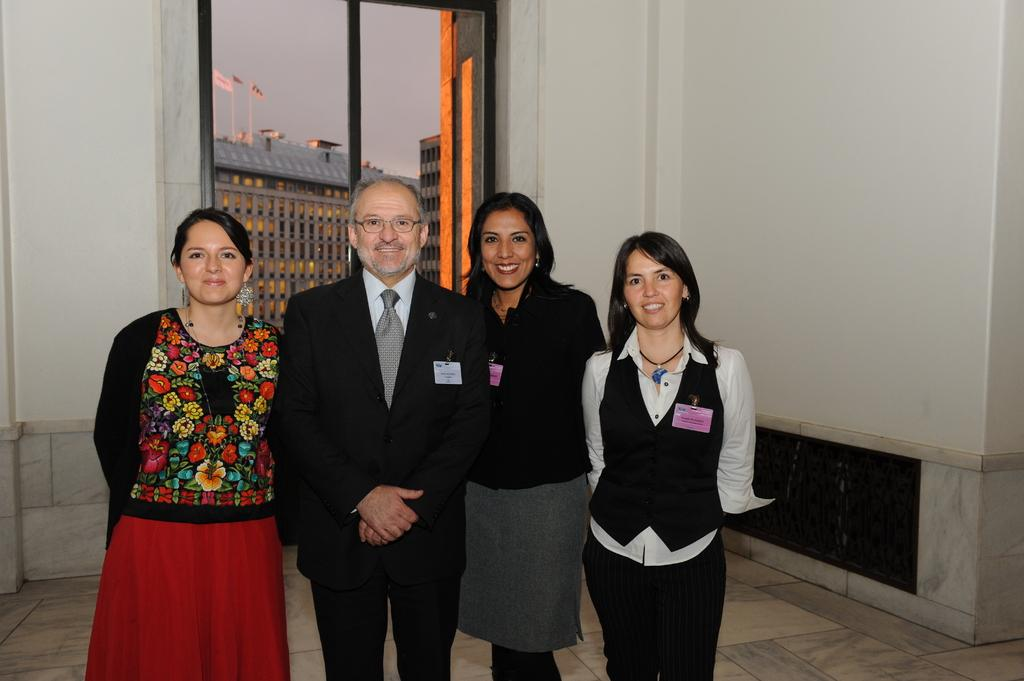Who or what is present in the image? There are people in the image. What can be seen beneath the people's feet? The ground is visible in the image. What is the background of the image composed of? There is a wall in the image, and there are buildings in the image. What material is present in the image that is typically transparent? Glass is present in the image. What can be seen waving in the wind in the image? Flags are visible in the image. What part of the natural environment is visible in the image? The sky is visible in the image. What type of bubble can be seen floating in the image? There is no bubble present in the image. How do the letters in the image move around? There are no letters present in the image, so they cannot move around. 